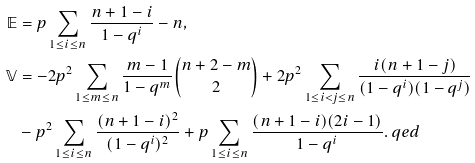Convert formula to latex. <formula><loc_0><loc_0><loc_500><loc_500>\mathbb { E } & = p \sum _ { 1 \leq i \leq n } \frac { n + 1 - i } { 1 - q ^ { i } } - n , \\ \mathbb { V } & = - 2 p ^ { 2 } \sum _ { 1 \leq m \leq n } \frac { m - 1 } { 1 - q ^ { m } } \binom { n + 2 - m } { 2 } + 2 p ^ { 2 } \sum _ { 1 \leq i < j \leq n } \frac { i ( n + 1 - j ) } { ( 1 - q ^ { i } ) ( 1 - q ^ { j } ) } \\ & - p ^ { 2 } \sum _ { 1 \leq i \leq n } \frac { ( n + 1 - i ) ^ { 2 } } { ( 1 - q ^ { i } ) ^ { 2 } } + p \sum _ { 1 \leq i \leq n } \frac { ( n + 1 - i ) ( 2 i - 1 ) } { 1 - q ^ { i } } . \ q e d</formula> 